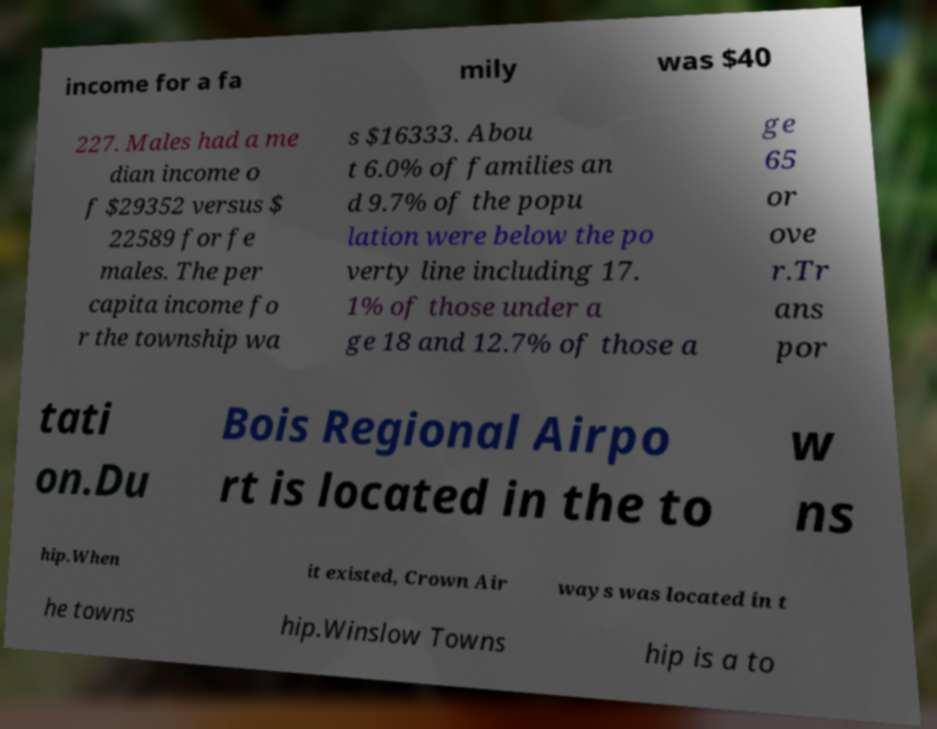For documentation purposes, I need the text within this image transcribed. Could you provide that? income for a fa mily was $40 227. Males had a me dian income o f $29352 versus $ 22589 for fe males. The per capita income fo r the township wa s $16333. Abou t 6.0% of families an d 9.7% of the popu lation were below the po verty line including 17. 1% of those under a ge 18 and 12.7% of those a ge 65 or ove r.Tr ans por tati on.Du Bois Regional Airpo rt is located in the to w ns hip.When it existed, Crown Air ways was located in t he towns hip.Winslow Towns hip is a to 